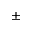<formula> <loc_0><loc_0><loc_500><loc_500>\pm</formula> 